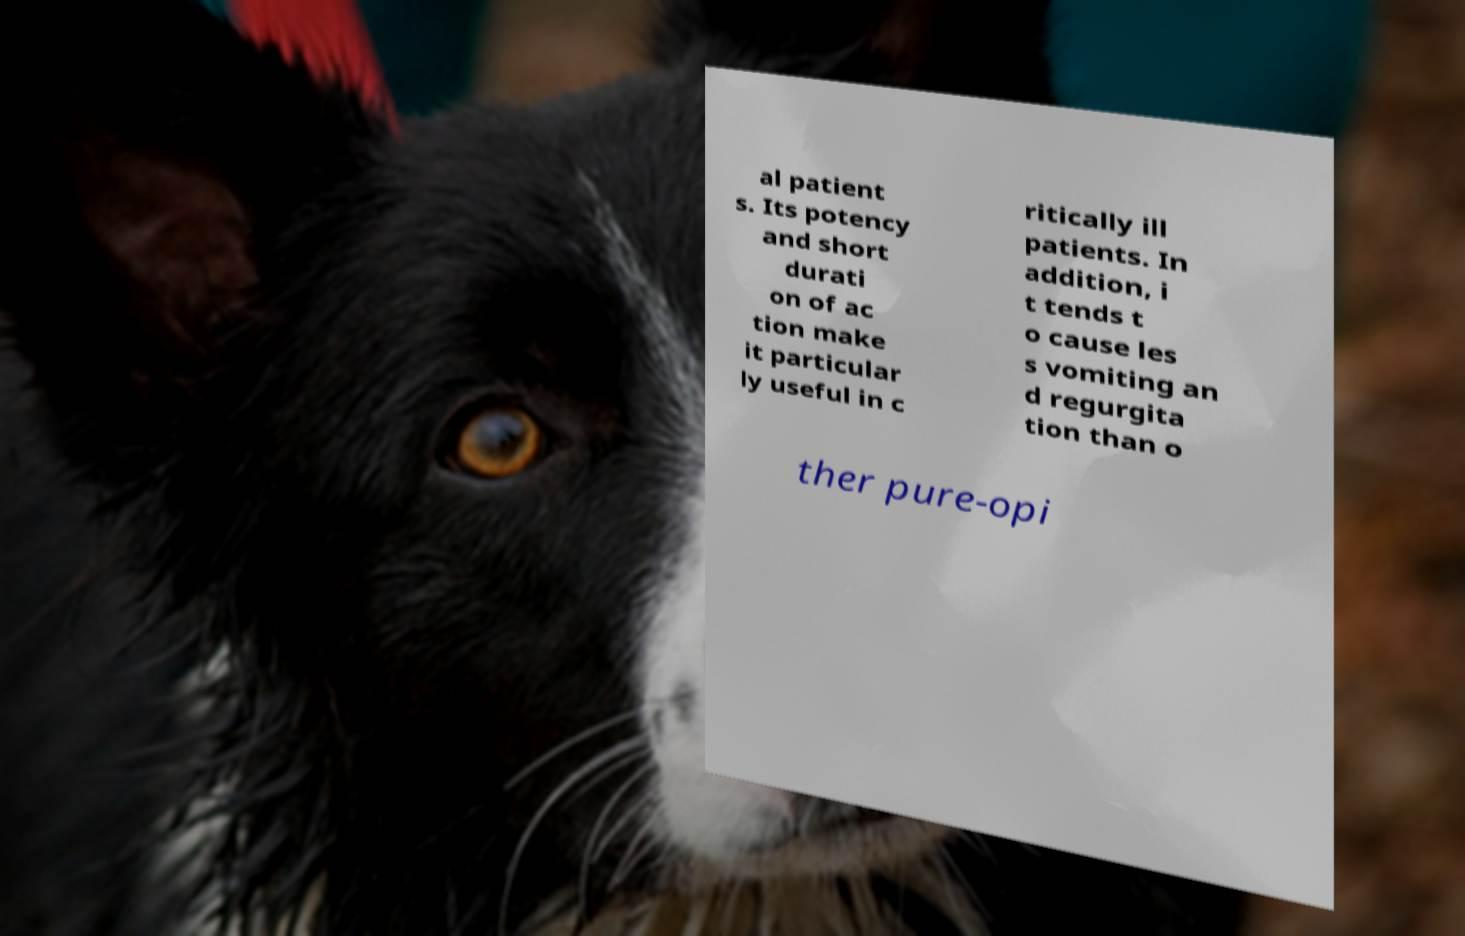Can you read and provide the text displayed in the image?This photo seems to have some interesting text. Can you extract and type it out for me? al patient s. Its potency and short durati on of ac tion make it particular ly useful in c ritically ill patients. In addition, i t tends t o cause les s vomiting an d regurgita tion than o ther pure-opi 